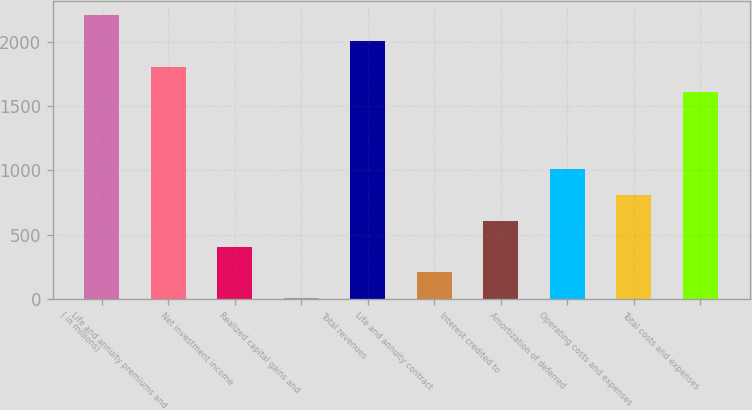Convert chart to OTSL. <chart><loc_0><loc_0><loc_500><loc_500><bar_chart><fcel>( in millions)<fcel>Life and annuity premiums and<fcel>Net investment income<fcel>Realized capital gains and<fcel>Total revenues<fcel>Life and annuity contract<fcel>Interest credited to<fcel>Amortization of deferred<fcel>Operating costs and expenses<fcel>Total costs and expenses<nl><fcel>2205.8<fcel>1806.2<fcel>407.6<fcel>8<fcel>2006<fcel>207.8<fcel>607.4<fcel>1007<fcel>807.2<fcel>1606.4<nl></chart> 